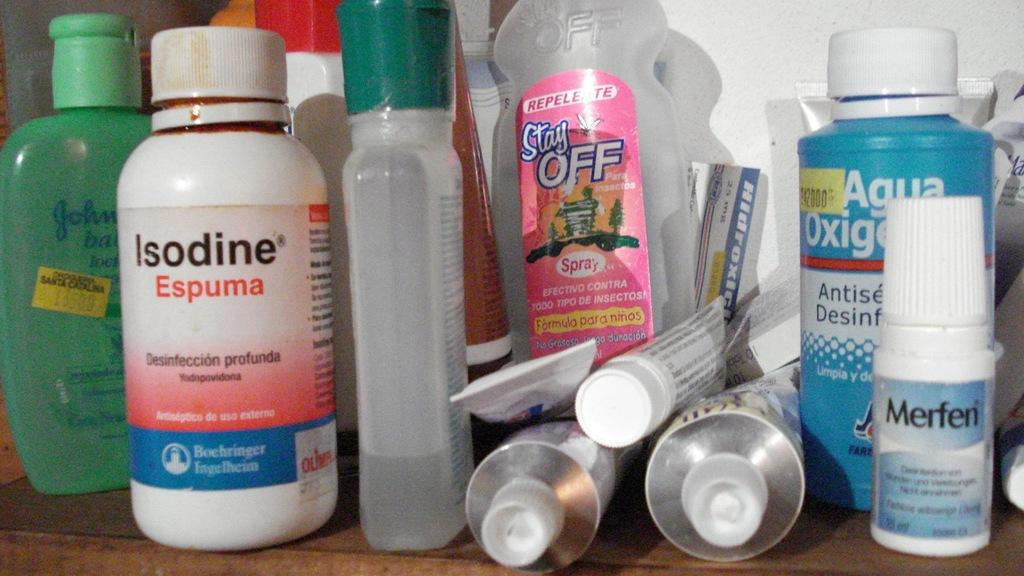<image>
Give a short and clear explanation of the subsequent image. Variety of health care products Merfen, Isodine, Stay off repellent 